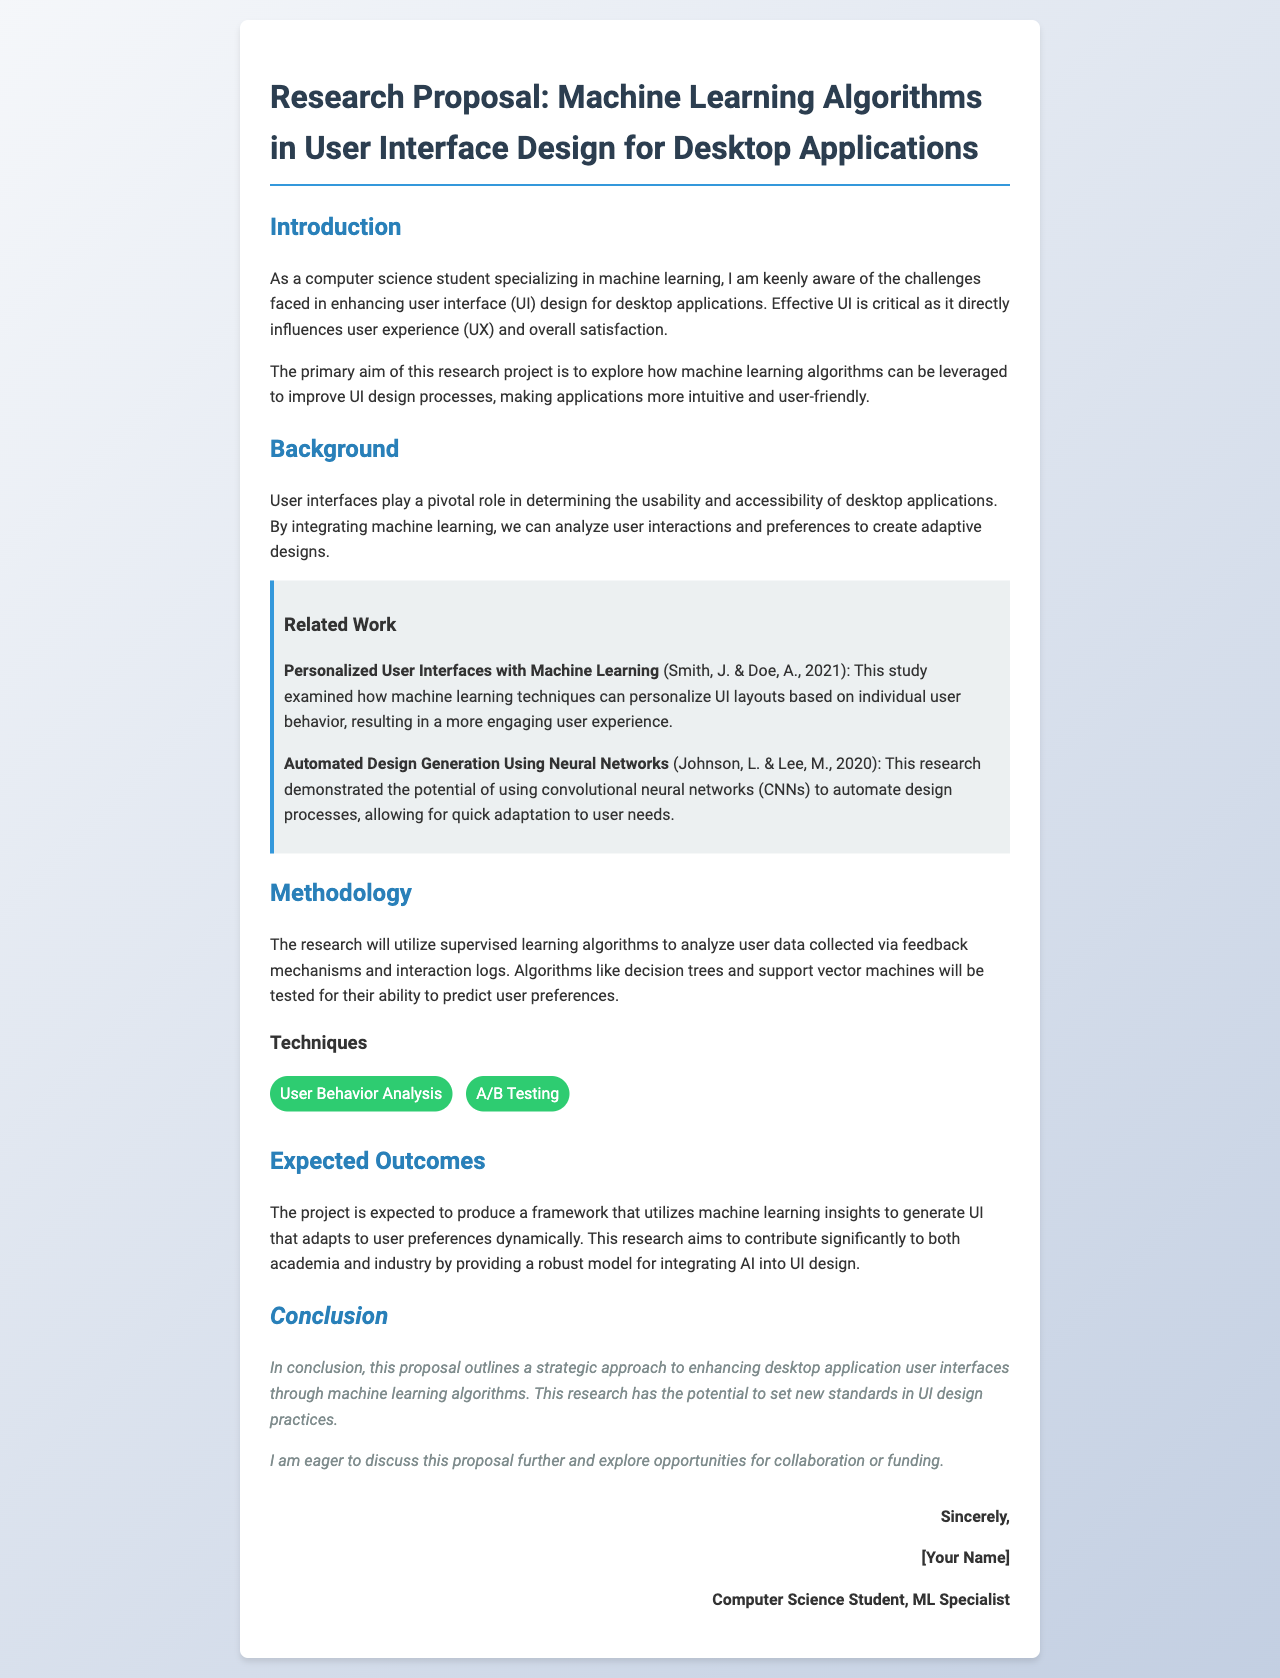What is the title of the research proposal? The title of the proposal is stated prominently at the top of the document.
Answer: Machine Learning Algorithms in User Interface Design for Desktop Applications Who authored the related work on personalized user interfaces? The related work discusses personalized user interfaces and names the authors.
Answer: Smith, J. & Doe, A What algorithm types will be utilized in the methodology? The methodology section specifically lists the types of algorithms that will be tested.
Answer: Supervised learning algorithms Which section discusses the expected outcomes? The expected outcomes are outlined in a specific section of the document.
Answer: Expected Outcomes What is the primary aim of the research project? The introduction summarizes the main goal of the project concerning UI design.
Answer: Improve UI design processes What methodology technique focuses on user preferences? The methodology also specifies techniques used to analyze user data.
Answer: User Behavior Analysis When was the related work on automated design generation published? The document specifies the publication year of the related work mentioned.
Answer: 2020 What is the concluding remark in the proposal? The conclusion section offers a summary statement of intent.
Answer: Set new standards in UI design practices 